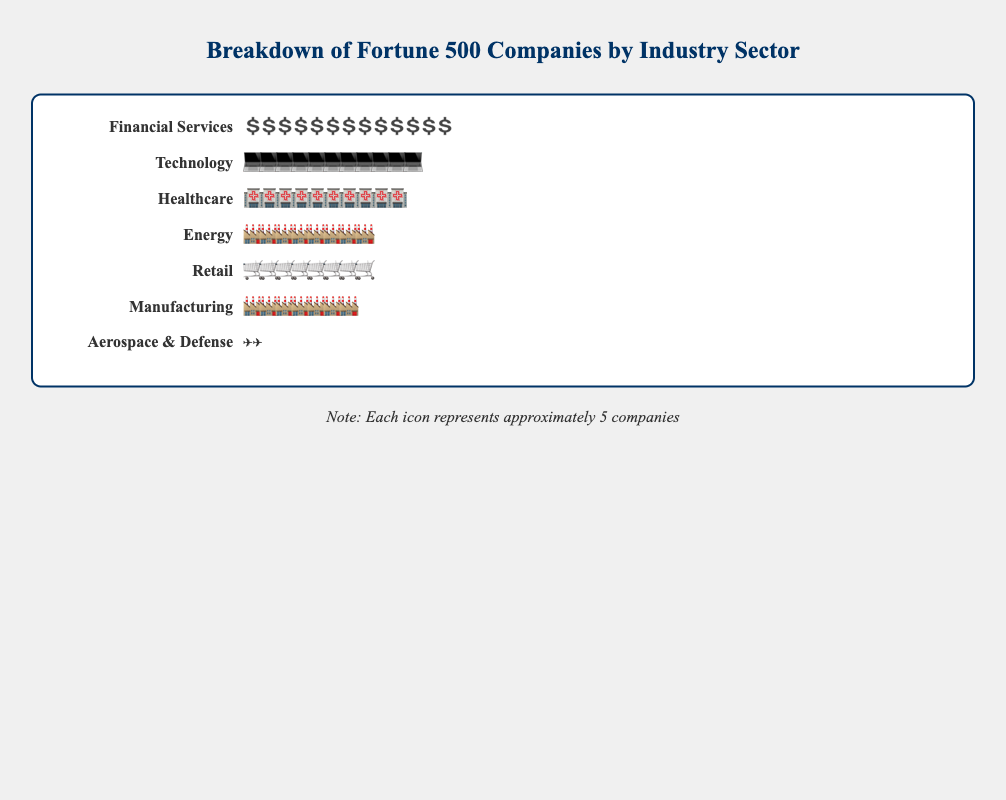What's the title of the figure? The title of the figure is located at the top and is in a larger, bold font. This is standard for identifying the main subject of the figure.
Answer: Breakdown of Fortune 500 Companies by Industry Sector How many companies are in the Healthcare sector? We can count the number of icons representing the Healthcare sector. According to the legend, each icon represents 5 companies. By counting the icons and multiplying by 5, we find the answer.
Answer: 49 Which sector has the most companies? We need to compare the number of icons in each sector. Financial Services has the most icons, indicating it has the most companies.
Answer: Financial Services How many total companies are represented in the figure? We need to sum the number of companies in each sector. Thus, 65 + 54 + 49 + 41 + 38 + 35 + 12 = 294.
Answer: 294 How many more companies are there in Technology than in Retail? First, identify the number of companies in each sector: Technology (54) and Retail (38). Then, calculate the difference: 54 - 38 = 16.
Answer: 16 What percentage of the total companies is in the Energy sector? First, identify the number of companies in the Energy sector (41). Then, calculate the total number of companies (294). The percentage is calculated as (41 / 294) * 100 ≈ 13.95%.
Answer: ~14% Compare the number of companies in the Technology and Manufacturing sectors. Which one has more, and by how many? Identify the number of companies in Technology (54) and Manufacturing (35). Calculate the difference: 54 - 35 = 19. Technology has more companies than Manufacturing by 19.
Answer: Technology, 19 more companies What is the ratio of companies in Financial Services to those in Aerospace & Defense? Identify the number of companies in Financial Services (65) and in Aerospace & Defense (12). The ratio is 65:12. Simplify if needed: 65 ÷ 5 = 13 and 12 ÷ 5 = 2.4. Thus, the simplified ratio is approximately 13:2.
Answer: 13:2 How many sectors have more than 40 companies? Identify and count the sectors with more than 40 companies: Financial Services, Technology, Healthcare, and Energy.
Answer: 4 Which sector has the least number of companies and how many? By comparing all sectors, Aerospace & Defense has the least number of companies with only 12.
Answer: Aerospace & Defense, 12 